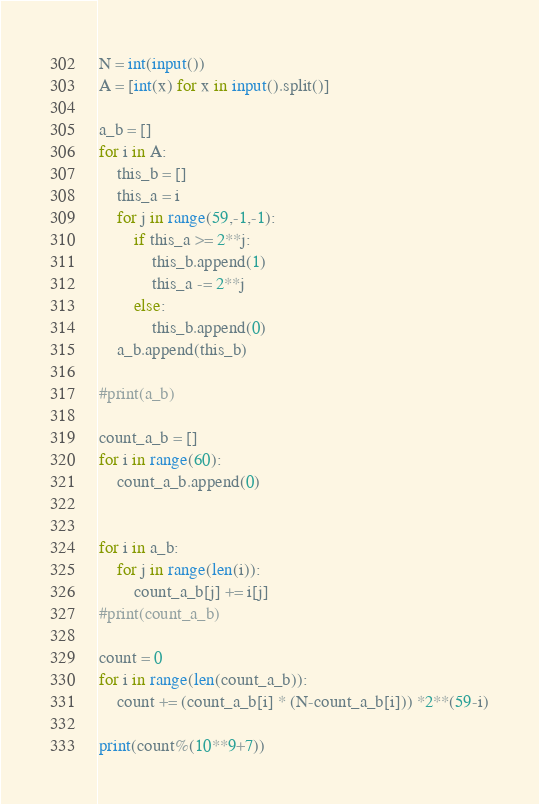Convert code to text. <code><loc_0><loc_0><loc_500><loc_500><_Python_>N = int(input())
A = [int(x) for x in input().split()]

a_b = []
for i in A:
    this_b = []
    this_a = i
    for j in range(59,-1,-1):
        if this_a >= 2**j:
            this_b.append(1)
            this_a -= 2**j
        else:
            this_b.append(0)
    a_b.append(this_b)
    
#print(a_b)

count_a_b = []
for i in range(60):
    count_a_b.append(0)

    
for i in a_b:
    for j in range(len(i)):
        count_a_b[j] += i[j]
#print(count_a_b)

count = 0
for i in range(len(count_a_b)):
    count += (count_a_b[i] * (N-count_a_b[i])) *2**(59-i)
    
print(count%(10**9+7))</code> 